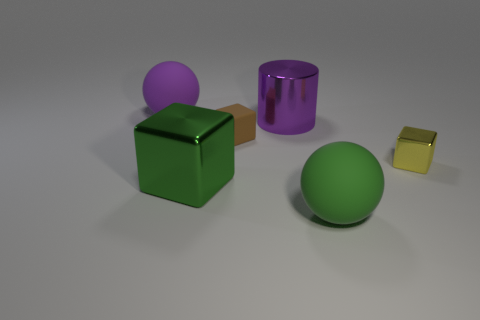Is the brown thing the same shape as the green metal object?
Your answer should be compact. Yes. What is the size of the metal cylinder?
Your answer should be compact. Large. Is the number of brown rubber blocks that are to the right of the green shiny cube greater than the number of big purple spheres in front of the small matte cube?
Provide a succinct answer. Yes. What is the color of the block that is made of the same material as the green sphere?
Give a very brief answer. Brown. The green thing that is the same shape as the tiny brown matte object is what size?
Provide a succinct answer. Large. What number of small things are purple rubber balls or purple cylinders?
Offer a very short reply. 0. Does the ball in front of the green cube have the same material as the green object behind the large green sphere?
Your answer should be very brief. No. What is the large ball that is left of the large cylinder made of?
Provide a succinct answer. Rubber. How many metal things are either blue balls or big green spheres?
Ensure brevity in your answer.  0. What color is the sphere that is in front of the ball that is behind the yellow block?
Keep it short and to the point. Green. 